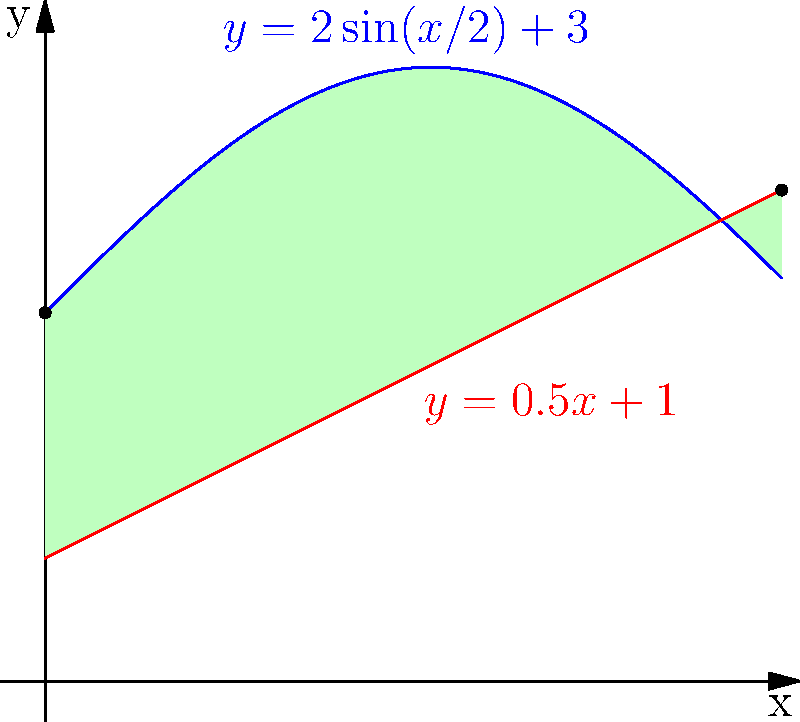As an event coordinator, you're tasked with calculating the area of an irregularly shaped section of the course bounded by two functions: $y = 2\sin(x/2) + 3$ and $y = 0.5x + 1$, from $x = 0$ to $x = 6$. This area will be used to determine the optimal placement of nutrition and hydration stations. Calculate the area of this section using integration. To find the area between two curves, we need to integrate the difference of the upper and lower functions from the left boundary to the right boundary. Here's how we can solve this step-by-step:

1) Identify the upper and lower functions:
   Upper function: $f(x) = 2\sin(x/2) + 3$
   Lower function: $g(x) = 0.5x + 1$

2) Set up the integral:
   Area = $\int_0^6 [f(x) - g(x)] dx$

3) Substitute the functions:
   Area = $\int_0^6 [(2\sin(x/2) + 3) - (0.5x + 1)] dx$

4) Simplify the integrand:
   Area = $\int_0^6 [2\sin(x/2) - 0.5x + 2] dx$

5) Integrate each term:
   $\int 2\sin(x/2) dx = -4\cos(x/2)$
   $\int -0.5x dx = -0.25x^2$
   $\int 2 dx = 2x$

6) Apply the fundamental theorem of calculus:
   Area = $[-4\cos(x/2) - 0.25x^2 + 2x]_0^6$

7) Evaluate at the bounds:
   Area = $[-4\cos(3) - 0.25(6)^2 + 2(6)] - [-4\cos(0) - 0.25(0)^2 + 2(0)]$

8) Simplify:
   Area = $[-4\cos(3) - 9 + 12] - [-4 + 0 + 0]$
   Area = $[-4\cos(3) + 3] + 4$
   Area = $-4\cos(3) + 7$

9) Calculate the final value (rounded to two decimal places):
   Area ≈ 10.62 square units
Answer: 10.62 square units 